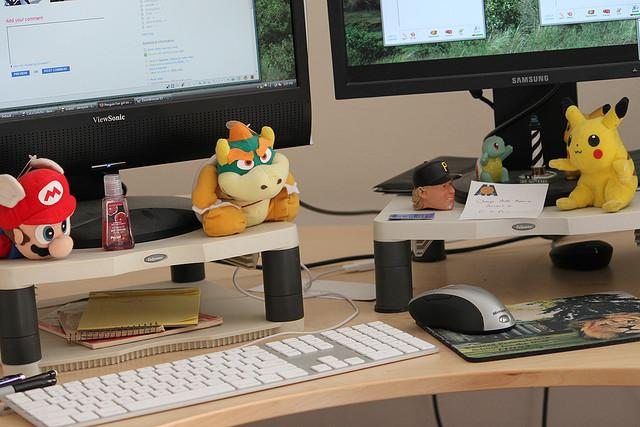What video game does the user of this office space like? Please explain your reasoning. super mario. There is a stuffed mario on the riser. 